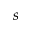<formula> <loc_0><loc_0><loc_500><loc_500>s</formula> 